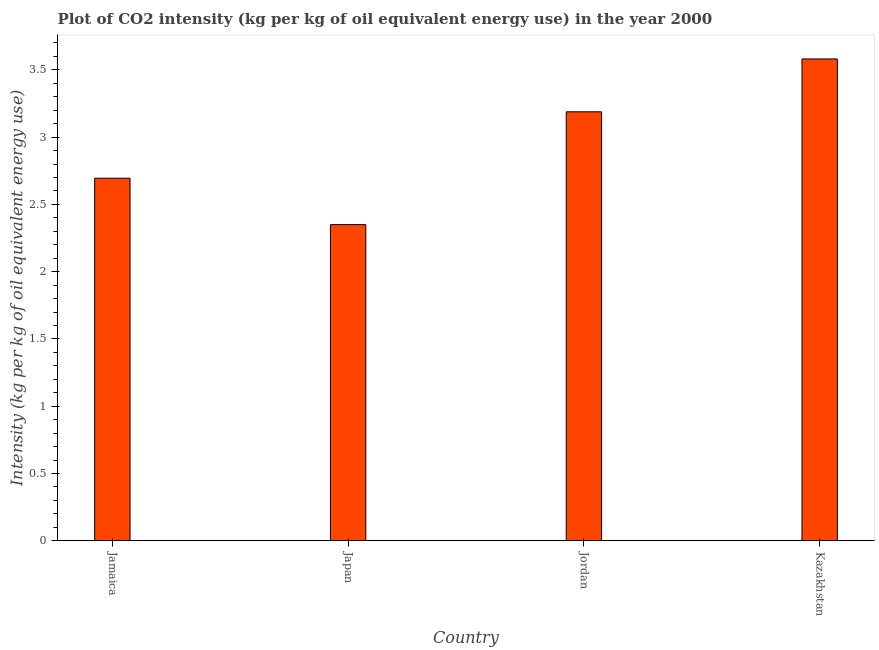Does the graph contain any zero values?
Your answer should be very brief. No. Does the graph contain grids?
Make the answer very short. No. What is the title of the graph?
Your response must be concise. Plot of CO2 intensity (kg per kg of oil equivalent energy use) in the year 2000. What is the label or title of the Y-axis?
Make the answer very short. Intensity (kg per kg of oil equivalent energy use). What is the co2 intensity in Kazakhstan?
Give a very brief answer. 3.58. Across all countries, what is the maximum co2 intensity?
Offer a very short reply. 3.58. Across all countries, what is the minimum co2 intensity?
Your response must be concise. 2.35. In which country was the co2 intensity maximum?
Ensure brevity in your answer.  Kazakhstan. What is the sum of the co2 intensity?
Give a very brief answer. 11.81. What is the difference between the co2 intensity in Jordan and Kazakhstan?
Provide a succinct answer. -0.39. What is the average co2 intensity per country?
Provide a succinct answer. 2.95. What is the median co2 intensity?
Provide a short and direct response. 2.94. What is the ratio of the co2 intensity in Jamaica to that in Jordan?
Your answer should be very brief. 0.84. Is the difference between the co2 intensity in Jamaica and Kazakhstan greater than the difference between any two countries?
Your answer should be very brief. No. What is the difference between the highest and the second highest co2 intensity?
Offer a terse response. 0.39. What is the difference between the highest and the lowest co2 intensity?
Offer a terse response. 1.23. Are all the bars in the graph horizontal?
Offer a very short reply. No. What is the difference between two consecutive major ticks on the Y-axis?
Provide a succinct answer. 0.5. Are the values on the major ticks of Y-axis written in scientific E-notation?
Offer a terse response. No. What is the Intensity (kg per kg of oil equivalent energy use) in Jamaica?
Your answer should be very brief. 2.69. What is the Intensity (kg per kg of oil equivalent energy use) in Japan?
Offer a terse response. 2.35. What is the Intensity (kg per kg of oil equivalent energy use) of Jordan?
Your answer should be compact. 3.19. What is the Intensity (kg per kg of oil equivalent energy use) in Kazakhstan?
Your answer should be compact. 3.58. What is the difference between the Intensity (kg per kg of oil equivalent energy use) in Jamaica and Japan?
Your answer should be compact. 0.35. What is the difference between the Intensity (kg per kg of oil equivalent energy use) in Jamaica and Jordan?
Your answer should be compact. -0.49. What is the difference between the Intensity (kg per kg of oil equivalent energy use) in Jamaica and Kazakhstan?
Ensure brevity in your answer.  -0.89. What is the difference between the Intensity (kg per kg of oil equivalent energy use) in Japan and Jordan?
Ensure brevity in your answer.  -0.84. What is the difference between the Intensity (kg per kg of oil equivalent energy use) in Japan and Kazakhstan?
Provide a succinct answer. -1.23. What is the difference between the Intensity (kg per kg of oil equivalent energy use) in Jordan and Kazakhstan?
Offer a terse response. -0.39. What is the ratio of the Intensity (kg per kg of oil equivalent energy use) in Jamaica to that in Japan?
Offer a terse response. 1.15. What is the ratio of the Intensity (kg per kg of oil equivalent energy use) in Jamaica to that in Jordan?
Offer a terse response. 0.84. What is the ratio of the Intensity (kg per kg of oil equivalent energy use) in Jamaica to that in Kazakhstan?
Provide a short and direct response. 0.75. What is the ratio of the Intensity (kg per kg of oil equivalent energy use) in Japan to that in Jordan?
Make the answer very short. 0.74. What is the ratio of the Intensity (kg per kg of oil equivalent energy use) in Japan to that in Kazakhstan?
Give a very brief answer. 0.66. What is the ratio of the Intensity (kg per kg of oil equivalent energy use) in Jordan to that in Kazakhstan?
Give a very brief answer. 0.89. 